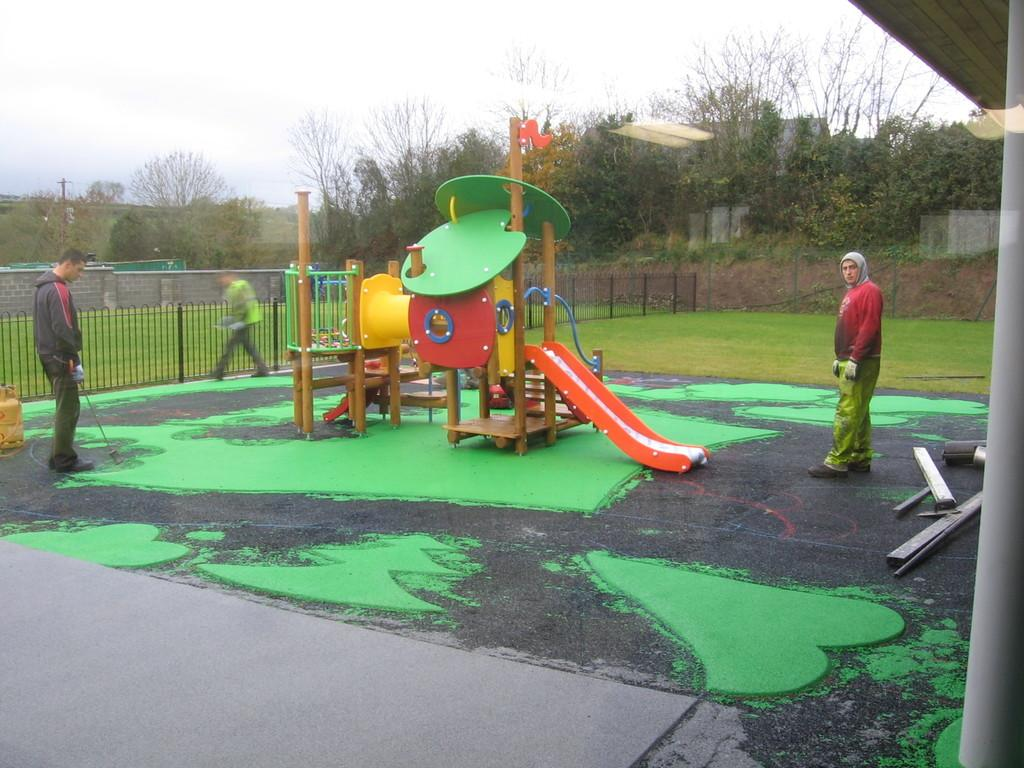What is the main feature in the image? There is a slide in the image. How many people are present in the image? Three people are standing in the image. What is on the left side of the image? There is a fence on the left side of the image. What type of vegetation is visible in the image? There is grass in the image. What else can be seen in the image besides the slide and people? There are trees in the image. What is visible in the background of the image? There are buildings in the background of the image. What is visible at the top of the image? The sky is visible at the top of the image. What type of plants are being harvested in the field in the image? There is no field or plants being harvested in the image; it features a slide, three people, a fence, grass, trees, buildings, and a sky. 